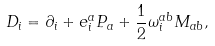<formula> <loc_0><loc_0><loc_500><loc_500>D _ { i } = \partial _ { i } + e _ { i } ^ { a } P _ { a } + \frac { 1 } { 2 } \omega _ { i } ^ { a b } M _ { a b } ,</formula> 